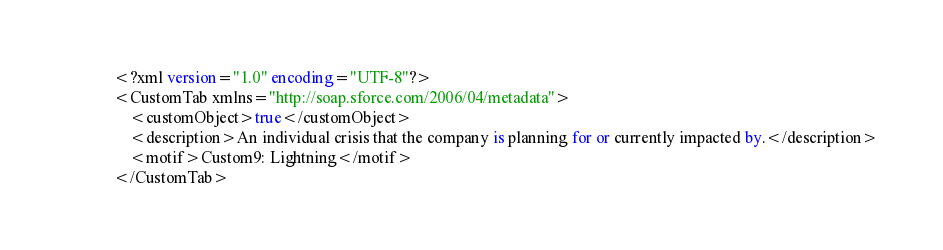Convert code to text. <code><loc_0><loc_0><loc_500><loc_500><_SQL_><?xml version="1.0" encoding="UTF-8"?>
<CustomTab xmlns="http://soap.sforce.com/2006/04/metadata">
    <customObject>true</customObject>
    <description>An individual crisis that the company is planning for or currently impacted by.</description>
    <motif>Custom9: Lightning</motif>
</CustomTab>
</code> 